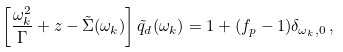Convert formula to latex. <formula><loc_0><loc_0><loc_500><loc_500>\left [ \frac { \omega _ { k } ^ { 2 } } { \Gamma } + z - \tilde { \Sigma } ( \omega _ { k } ) \right ] \tilde { q } _ { d } ( \omega _ { k } ) = 1 + ( f _ { p } - 1 ) \delta _ { \omega _ { k } , 0 } \, ,</formula> 